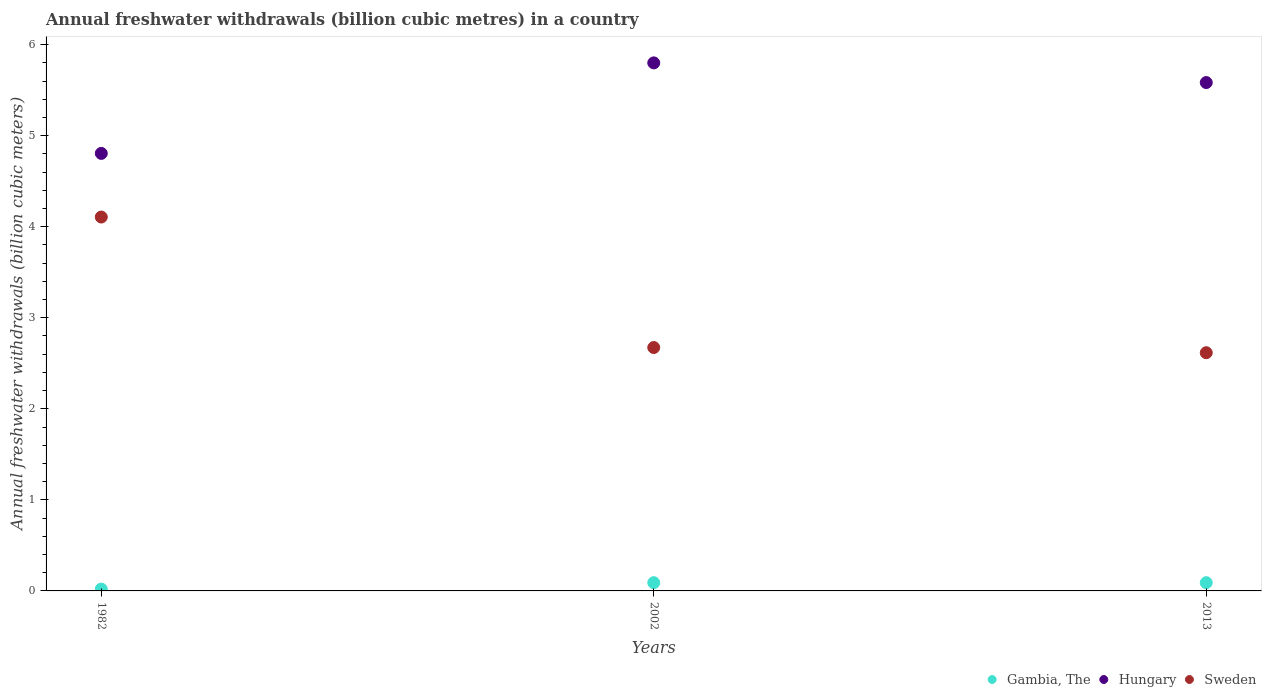What is the annual freshwater withdrawals in Gambia, The in 2002?
Ensure brevity in your answer.  0.09. Across all years, what is the maximum annual freshwater withdrawals in Gambia, The?
Give a very brief answer. 0.09. Across all years, what is the minimum annual freshwater withdrawals in Sweden?
Keep it short and to the point. 2.62. What is the total annual freshwater withdrawals in Sweden in the graph?
Ensure brevity in your answer.  9.39. What is the difference between the annual freshwater withdrawals in Hungary in 1982 and that in 2013?
Offer a terse response. -0.78. What is the difference between the annual freshwater withdrawals in Hungary in 2013 and the annual freshwater withdrawals in Gambia, The in 1982?
Provide a short and direct response. 5.56. What is the average annual freshwater withdrawals in Hungary per year?
Offer a very short reply. 5.4. In the year 2013, what is the difference between the annual freshwater withdrawals in Sweden and annual freshwater withdrawals in Hungary?
Provide a succinct answer. -2.97. What is the ratio of the annual freshwater withdrawals in Hungary in 1982 to that in 2002?
Provide a succinct answer. 0.83. Is the annual freshwater withdrawals in Hungary in 1982 less than that in 2013?
Your response must be concise. Yes. Is the difference between the annual freshwater withdrawals in Sweden in 1982 and 2013 greater than the difference between the annual freshwater withdrawals in Hungary in 1982 and 2013?
Provide a succinct answer. Yes. What is the difference between the highest and the second highest annual freshwater withdrawals in Sweden?
Keep it short and to the point. 1.43. What is the difference between the highest and the lowest annual freshwater withdrawals in Gambia, The?
Your answer should be compact. 0.07. In how many years, is the annual freshwater withdrawals in Sweden greater than the average annual freshwater withdrawals in Sweden taken over all years?
Ensure brevity in your answer.  1. Is the sum of the annual freshwater withdrawals in Hungary in 1982 and 2002 greater than the maximum annual freshwater withdrawals in Sweden across all years?
Your response must be concise. Yes. Is it the case that in every year, the sum of the annual freshwater withdrawals in Sweden and annual freshwater withdrawals in Gambia, The  is greater than the annual freshwater withdrawals in Hungary?
Ensure brevity in your answer.  No. Is the annual freshwater withdrawals in Gambia, The strictly greater than the annual freshwater withdrawals in Hungary over the years?
Ensure brevity in your answer.  No. Is the annual freshwater withdrawals in Sweden strictly less than the annual freshwater withdrawals in Gambia, The over the years?
Offer a terse response. No. How many dotlines are there?
Your answer should be compact. 3. How many years are there in the graph?
Your answer should be very brief. 3. Are the values on the major ticks of Y-axis written in scientific E-notation?
Offer a terse response. No. Does the graph contain grids?
Your answer should be very brief. No. Where does the legend appear in the graph?
Give a very brief answer. Bottom right. What is the title of the graph?
Your answer should be very brief. Annual freshwater withdrawals (billion cubic metres) in a country. Does "Andorra" appear as one of the legend labels in the graph?
Give a very brief answer. No. What is the label or title of the Y-axis?
Ensure brevity in your answer.  Annual freshwater withdrawals (billion cubic meters). What is the Annual freshwater withdrawals (billion cubic meters) of Hungary in 1982?
Ensure brevity in your answer.  4.8. What is the Annual freshwater withdrawals (billion cubic meters) in Sweden in 1982?
Make the answer very short. 4.11. What is the Annual freshwater withdrawals (billion cubic meters) in Gambia, The in 2002?
Give a very brief answer. 0.09. What is the Annual freshwater withdrawals (billion cubic meters) in Hungary in 2002?
Keep it short and to the point. 5.8. What is the Annual freshwater withdrawals (billion cubic meters) of Sweden in 2002?
Your response must be concise. 2.67. What is the Annual freshwater withdrawals (billion cubic meters) in Gambia, The in 2013?
Keep it short and to the point. 0.09. What is the Annual freshwater withdrawals (billion cubic meters) in Hungary in 2013?
Keep it short and to the point. 5.58. What is the Annual freshwater withdrawals (billion cubic meters) in Sweden in 2013?
Give a very brief answer. 2.62. Across all years, what is the maximum Annual freshwater withdrawals (billion cubic meters) in Gambia, The?
Keep it short and to the point. 0.09. Across all years, what is the maximum Annual freshwater withdrawals (billion cubic meters) in Hungary?
Your response must be concise. 5.8. Across all years, what is the maximum Annual freshwater withdrawals (billion cubic meters) of Sweden?
Make the answer very short. 4.11. Across all years, what is the minimum Annual freshwater withdrawals (billion cubic meters) in Hungary?
Offer a very short reply. 4.8. Across all years, what is the minimum Annual freshwater withdrawals (billion cubic meters) in Sweden?
Your response must be concise. 2.62. What is the total Annual freshwater withdrawals (billion cubic meters) of Gambia, The in the graph?
Give a very brief answer. 0.2. What is the total Annual freshwater withdrawals (billion cubic meters) of Hungary in the graph?
Ensure brevity in your answer.  16.19. What is the total Annual freshwater withdrawals (billion cubic meters) in Sweden in the graph?
Provide a short and direct response. 9.39. What is the difference between the Annual freshwater withdrawals (billion cubic meters) in Gambia, The in 1982 and that in 2002?
Offer a terse response. -0.07. What is the difference between the Annual freshwater withdrawals (billion cubic meters) in Hungary in 1982 and that in 2002?
Offer a terse response. -0.99. What is the difference between the Annual freshwater withdrawals (billion cubic meters) in Sweden in 1982 and that in 2002?
Provide a succinct answer. 1.43. What is the difference between the Annual freshwater withdrawals (billion cubic meters) of Gambia, The in 1982 and that in 2013?
Keep it short and to the point. -0.07. What is the difference between the Annual freshwater withdrawals (billion cubic meters) of Hungary in 1982 and that in 2013?
Your answer should be very brief. -0.78. What is the difference between the Annual freshwater withdrawals (billion cubic meters) in Sweden in 1982 and that in 2013?
Your answer should be compact. 1.49. What is the difference between the Annual freshwater withdrawals (billion cubic meters) in Hungary in 2002 and that in 2013?
Make the answer very short. 0.22. What is the difference between the Annual freshwater withdrawals (billion cubic meters) in Sweden in 2002 and that in 2013?
Your answer should be very brief. 0.06. What is the difference between the Annual freshwater withdrawals (billion cubic meters) in Gambia, The in 1982 and the Annual freshwater withdrawals (billion cubic meters) in Hungary in 2002?
Provide a short and direct response. -5.78. What is the difference between the Annual freshwater withdrawals (billion cubic meters) in Gambia, The in 1982 and the Annual freshwater withdrawals (billion cubic meters) in Sweden in 2002?
Provide a short and direct response. -2.65. What is the difference between the Annual freshwater withdrawals (billion cubic meters) of Hungary in 1982 and the Annual freshwater withdrawals (billion cubic meters) of Sweden in 2002?
Your answer should be compact. 2.13. What is the difference between the Annual freshwater withdrawals (billion cubic meters) of Gambia, The in 1982 and the Annual freshwater withdrawals (billion cubic meters) of Hungary in 2013?
Your answer should be compact. -5.56. What is the difference between the Annual freshwater withdrawals (billion cubic meters) in Gambia, The in 1982 and the Annual freshwater withdrawals (billion cubic meters) in Sweden in 2013?
Make the answer very short. -2.6. What is the difference between the Annual freshwater withdrawals (billion cubic meters) of Hungary in 1982 and the Annual freshwater withdrawals (billion cubic meters) of Sweden in 2013?
Keep it short and to the point. 2.19. What is the difference between the Annual freshwater withdrawals (billion cubic meters) of Gambia, The in 2002 and the Annual freshwater withdrawals (billion cubic meters) of Hungary in 2013?
Give a very brief answer. -5.49. What is the difference between the Annual freshwater withdrawals (billion cubic meters) in Gambia, The in 2002 and the Annual freshwater withdrawals (billion cubic meters) in Sweden in 2013?
Give a very brief answer. -2.53. What is the difference between the Annual freshwater withdrawals (billion cubic meters) in Hungary in 2002 and the Annual freshwater withdrawals (billion cubic meters) in Sweden in 2013?
Offer a very short reply. 3.18. What is the average Annual freshwater withdrawals (billion cubic meters) in Gambia, The per year?
Provide a short and direct response. 0.07. What is the average Annual freshwater withdrawals (billion cubic meters) in Hungary per year?
Offer a very short reply. 5.4. What is the average Annual freshwater withdrawals (billion cubic meters) in Sweden per year?
Offer a terse response. 3.13. In the year 1982, what is the difference between the Annual freshwater withdrawals (billion cubic meters) in Gambia, The and Annual freshwater withdrawals (billion cubic meters) in Hungary?
Your response must be concise. -4.79. In the year 1982, what is the difference between the Annual freshwater withdrawals (billion cubic meters) of Gambia, The and Annual freshwater withdrawals (billion cubic meters) of Sweden?
Provide a succinct answer. -4.09. In the year 1982, what is the difference between the Annual freshwater withdrawals (billion cubic meters) in Hungary and Annual freshwater withdrawals (billion cubic meters) in Sweden?
Make the answer very short. 0.7. In the year 2002, what is the difference between the Annual freshwater withdrawals (billion cubic meters) in Gambia, The and Annual freshwater withdrawals (billion cubic meters) in Hungary?
Provide a short and direct response. -5.71. In the year 2002, what is the difference between the Annual freshwater withdrawals (billion cubic meters) of Gambia, The and Annual freshwater withdrawals (billion cubic meters) of Sweden?
Ensure brevity in your answer.  -2.58. In the year 2002, what is the difference between the Annual freshwater withdrawals (billion cubic meters) in Hungary and Annual freshwater withdrawals (billion cubic meters) in Sweden?
Make the answer very short. 3.13. In the year 2013, what is the difference between the Annual freshwater withdrawals (billion cubic meters) in Gambia, The and Annual freshwater withdrawals (billion cubic meters) in Hungary?
Your answer should be very brief. -5.49. In the year 2013, what is the difference between the Annual freshwater withdrawals (billion cubic meters) of Gambia, The and Annual freshwater withdrawals (billion cubic meters) of Sweden?
Ensure brevity in your answer.  -2.53. In the year 2013, what is the difference between the Annual freshwater withdrawals (billion cubic meters) in Hungary and Annual freshwater withdrawals (billion cubic meters) in Sweden?
Give a very brief answer. 2.97. What is the ratio of the Annual freshwater withdrawals (billion cubic meters) in Gambia, The in 1982 to that in 2002?
Keep it short and to the point. 0.22. What is the ratio of the Annual freshwater withdrawals (billion cubic meters) of Hungary in 1982 to that in 2002?
Your response must be concise. 0.83. What is the ratio of the Annual freshwater withdrawals (billion cubic meters) in Sweden in 1982 to that in 2002?
Your answer should be compact. 1.54. What is the ratio of the Annual freshwater withdrawals (billion cubic meters) in Gambia, The in 1982 to that in 2013?
Your response must be concise. 0.22. What is the ratio of the Annual freshwater withdrawals (billion cubic meters) of Hungary in 1982 to that in 2013?
Your response must be concise. 0.86. What is the ratio of the Annual freshwater withdrawals (billion cubic meters) of Sweden in 1982 to that in 2013?
Ensure brevity in your answer.  1.57. What is the ratio of the Annual freshwater withdrawals (billion cubic meters) of Gambia, The in 2002 to that in 2013?
Make the answer very short. 1. What is the ratio of the Annual freshwater withdrawals (billion cubic meters) of Hungary in 2002 to that in 2013?
Give a very brief answer. 1.04. What is the ratio of the Annual freshwater withdrawals (billion cubic meters) in Sweden in 2002 to that in 2013?
Ensure brevity in your answer.  1.02. What is the difference between the highest and the second highest Annual freshwater withdrawals (billion cubic meters) of Hungary?
Provide a succinct answer. 0.22. What is the difference between the highest and the second highest Annual freshwater withdrawals (billion cubic meters) of Sweden?
Provide a succinct answer. 1.43. What is the difference between the highest and the lowest Annual freshwater withdrawals (billion cubic meters) of Gambia, The?
Provide a succinct answer. 0.07. What is the difference between the highest and the lowest Annual freshwater withdrawals (billion cubic meters) of Sweden?
Give a very brief answer. 1.49. 